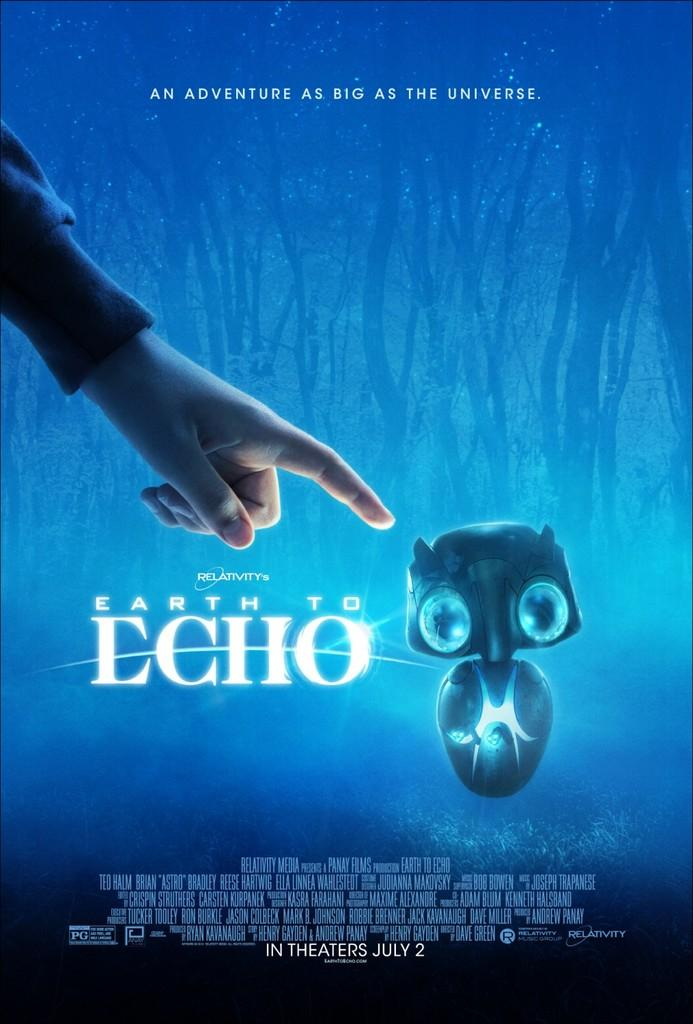<image>
Write a terse but informative summary of the picture. An advertisement for the movie Earth to Echo coming the theaters on July 2. 